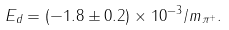Convert formula to latex. <formula><loc_0><loc_0><loc_500><loc_500>E _ { d } = ( - 1 . 8 \pm 0 . 2 ) \times 1 0 ^ { - 3 } / m _ { \pi ^ { + } } .</formula> 